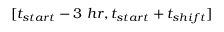<formula> <loc_0><loc_0><loc_500><loc_500>[ t _ { s t a r t } - 3 h r , t _ { s t a r t } + t _ { s h i f t } ]</formula> 